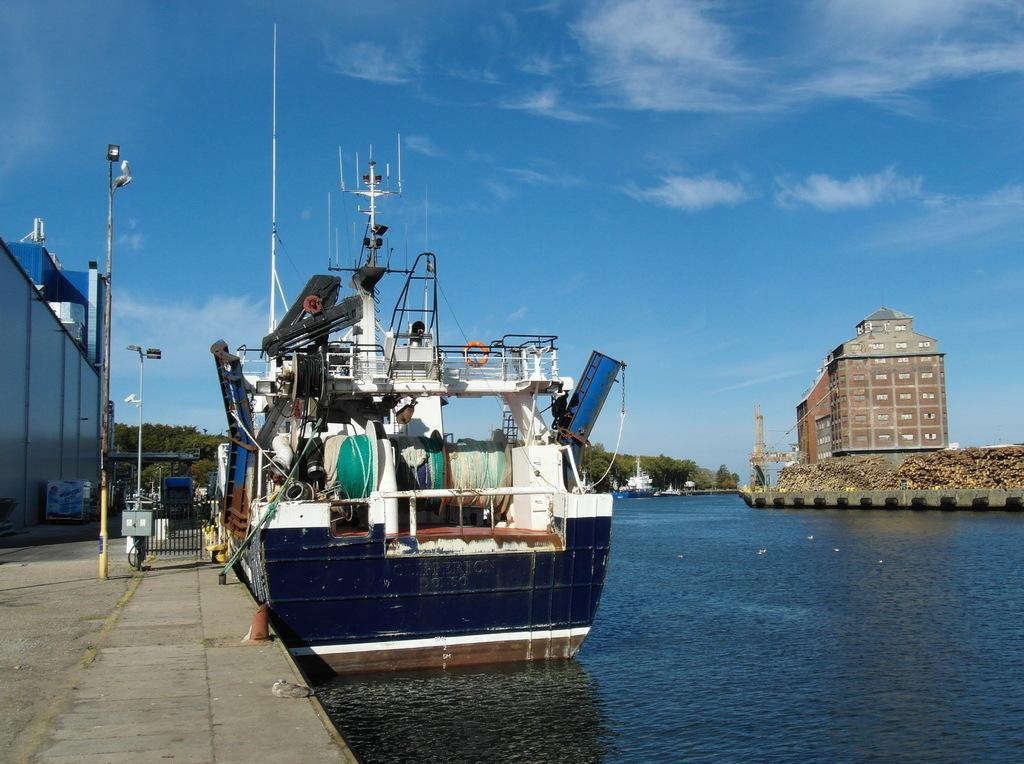What type of vehicle is in the image? There is a blue ship in the image. What is at the bottom of the image? There is water at the bottom of the image. What structures are to the left of the image? There is a building and a pole to the left of the image. What can be seen in the sky at the top of the image? There are clouds in the sky at the top of the image. Can you tell me how many crackers are floating in the water next to the ship? There are no crackers present in the image; it only features a blue ship, water, a building, a pole, and clouds in the sky. 